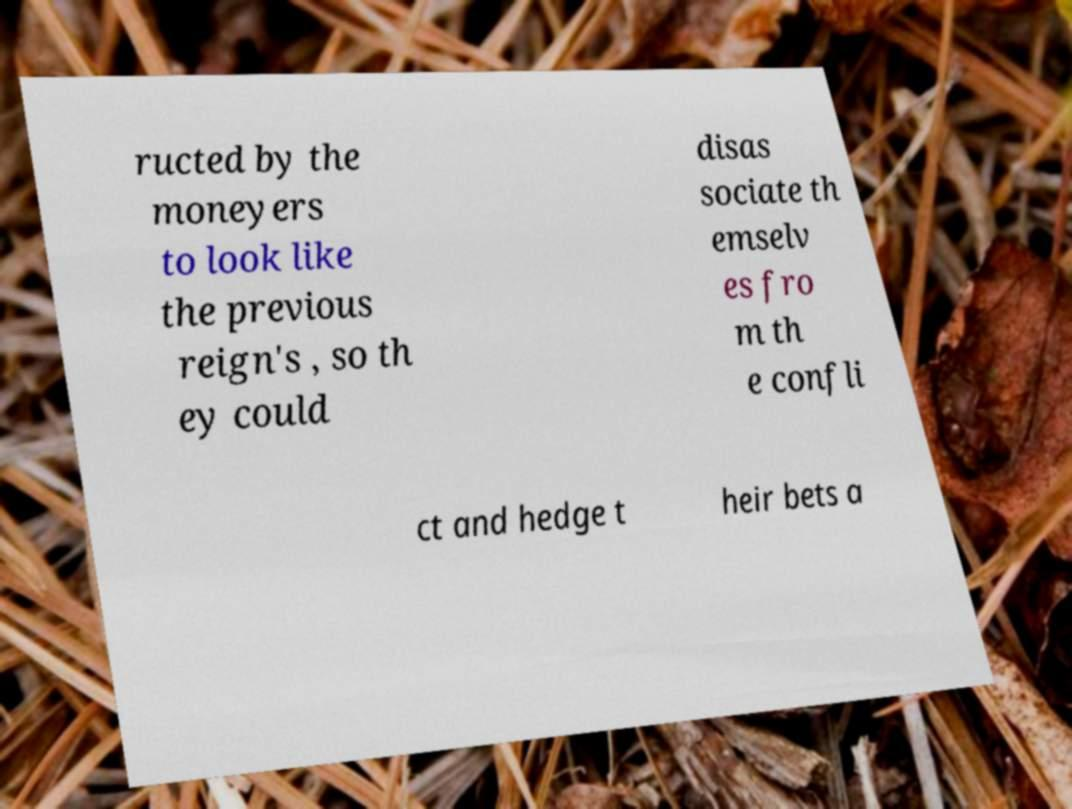I need the written content from this picture converted into text. Can you do that? ructed by the moneyers to look like the previous reign's , so th ey could disas sociate th emselv es fro m th e confli ct and hedge t heir bets a 